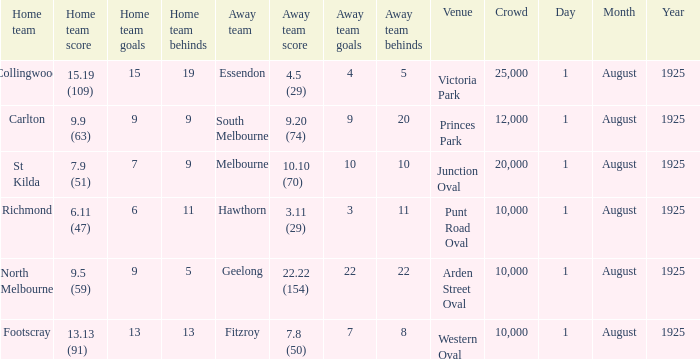Parse the full table. {'header': ['Home team', 'Home team score', 'Home team goals', 'Home team behinds', 'Away team', 'Away team score', 'Away team goals', 'Away team behinds', 'Venue', 'Crowd', 'Day', 'Month', 'Year'], 'rows': [['Collingwood', '15.19 (109)', '15', '19', 'Essendon', '4.5 (29)', '4', '5', 'Victoria Park', '25,000', '1', 'August', '1925'], ['Carlton', '9.9 (63)', '9', '9', 'South Melbourne', '9.20 (74)', '9', '20', 'Princes Park', '12,000', '1', 'August', '1925'], ['St Kilda', '7.9 (51)', '7', '9', 'Melbourne', '10.10 (70)', '10', '10', 'Junction Oval', '20,000', '1', 'August', '1925'], ['Richmond', '6.11 (47)', '6', '11', 'Hawthorn', '3.11 (29)', '3', '11', 'Punt Road Oval', '10,000', '1', 'August', '1925'], ['North Melbourne', '9.5 (59)', '9', '5', 'Geelong', '22.22 (154)', '22', '22', 'Arden Street Oval', '10,000', '1', 'August', '1925'], ['Footscray', '13.13 (91)', '13', '13', 'Fitzroy', '7.8 (50)', '7', '8', 'Western Oval', '10,000', '1', 'August', '1925']]} Of matches that had a home team score of 13.13 (91), which one had the largest crowd? 10000.0. 